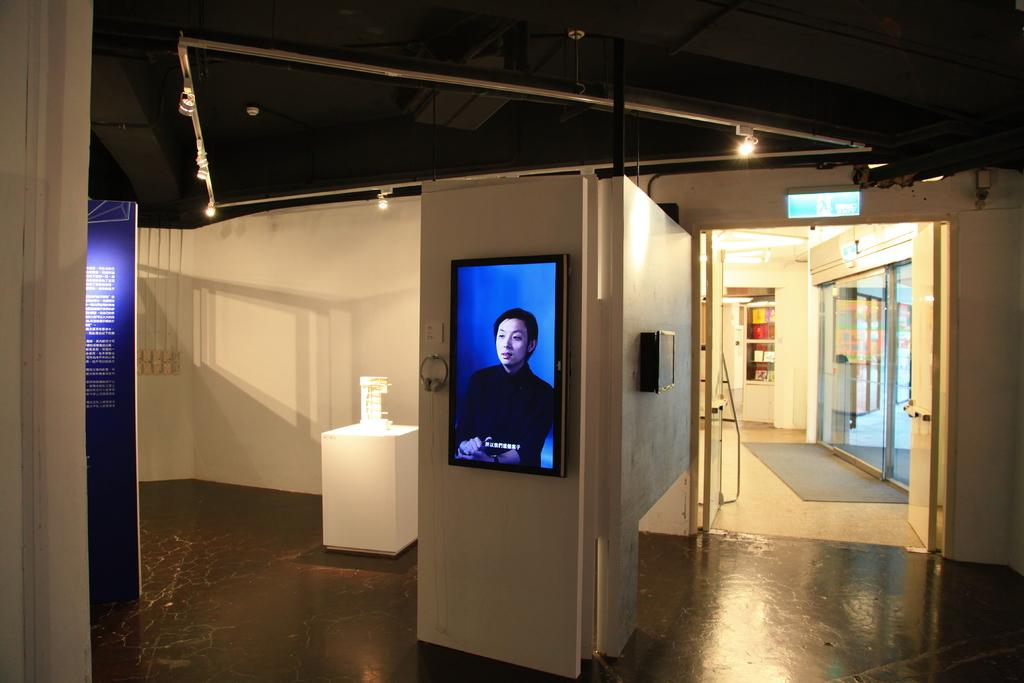What color are the walls in the image? The walls in the image are white. What electronic device is mounted on the wall? There is a television on the wall. How many doors can be seen in the image? There are doors visible in the image. What surface is underfoot in the image? There is a floor in the image. How many crackers are on the floor in the image? There are no crackers present in the image. What type of lizards can be seen crawling on the walls in the image? There are no lizards present in the image. 